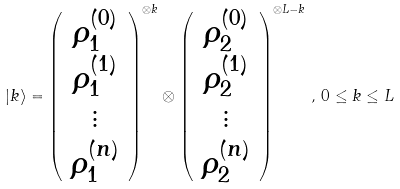Convert formula to latex. <formula><loc_0><loc_0><loc_500><loc_500>| k \rangle = \left ( \begin{array} { c } \rho _ { 1 } ^ { ( 0 ) } \\ \rho _ { 1 } ^ { ( 1 ) } \\ \vdots \\ \rho _ { 1 } ^ { ( n ) } \end{array} \right ) ^ { \otimes k } \otimes \left ( \begin{array} { c } \rho _ { 2 } ^ { ( 0 ) } \\ \rho _ { 2 } ^ { ( 1 ) } \\ \vdots \\ \rho _ { 2 } ^ { ( n ) } \end{array} \right ) ^ { \otimes L - k } \, , \, 0 \leq k \leq L</formula> 